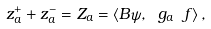Convert formula to latex. <formula><loc_0><loc_0><loc_500><loc_500>z _ { a } ^ { + } + z _ { a } ^ { - } = Z _ { a } = \langle B \psi , \ g _ { a } \ f \rangle \, ,</formula> 